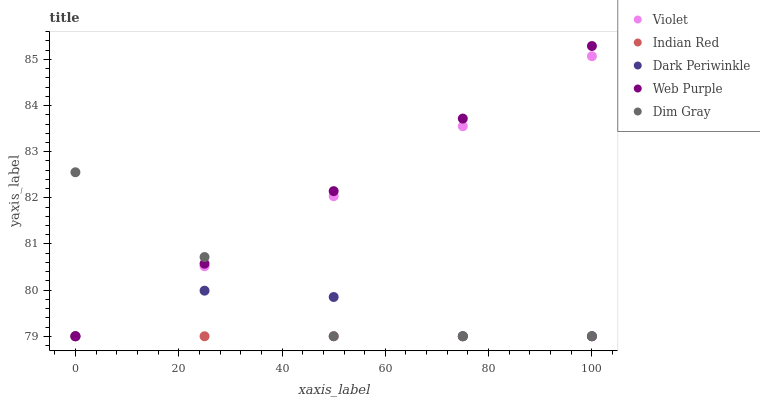Does Indian Red have the minimum area under the curve?
Answer yes or no. Yes. Does Web Purple have the maximum area under the curve?
Answer yes or no. Yes. Does Dim Gray have the minimum area under the curve?
Answer yes or no. No. Does Dim Gray have the maximum area under the curve?
Answer yes or no. No. Is Web Purple the smoothest?
Answer yes or no. Yes. Is Dark Periwinkle the roughest?
Answer yes or no. Yes. Is Dim Gray the smoothest?
Answer yes or no. No. Is Dim Gray the roughest?
Answer yes or no. No. Does Web Purple have the lowest value?
Answer yes or no. Yes. Does Web Purple have the highest value?
Answer yes or no. Yes. Does Dim Gray have the highest value?
Answer yes or no. No. Does Violet intersect Indian Red?
Answer yes or no. Yes. Is Violet less than Indian Red?
Answer yes or no. No. Is Violet greater than Indian Red?
Answer yes or no. No. 